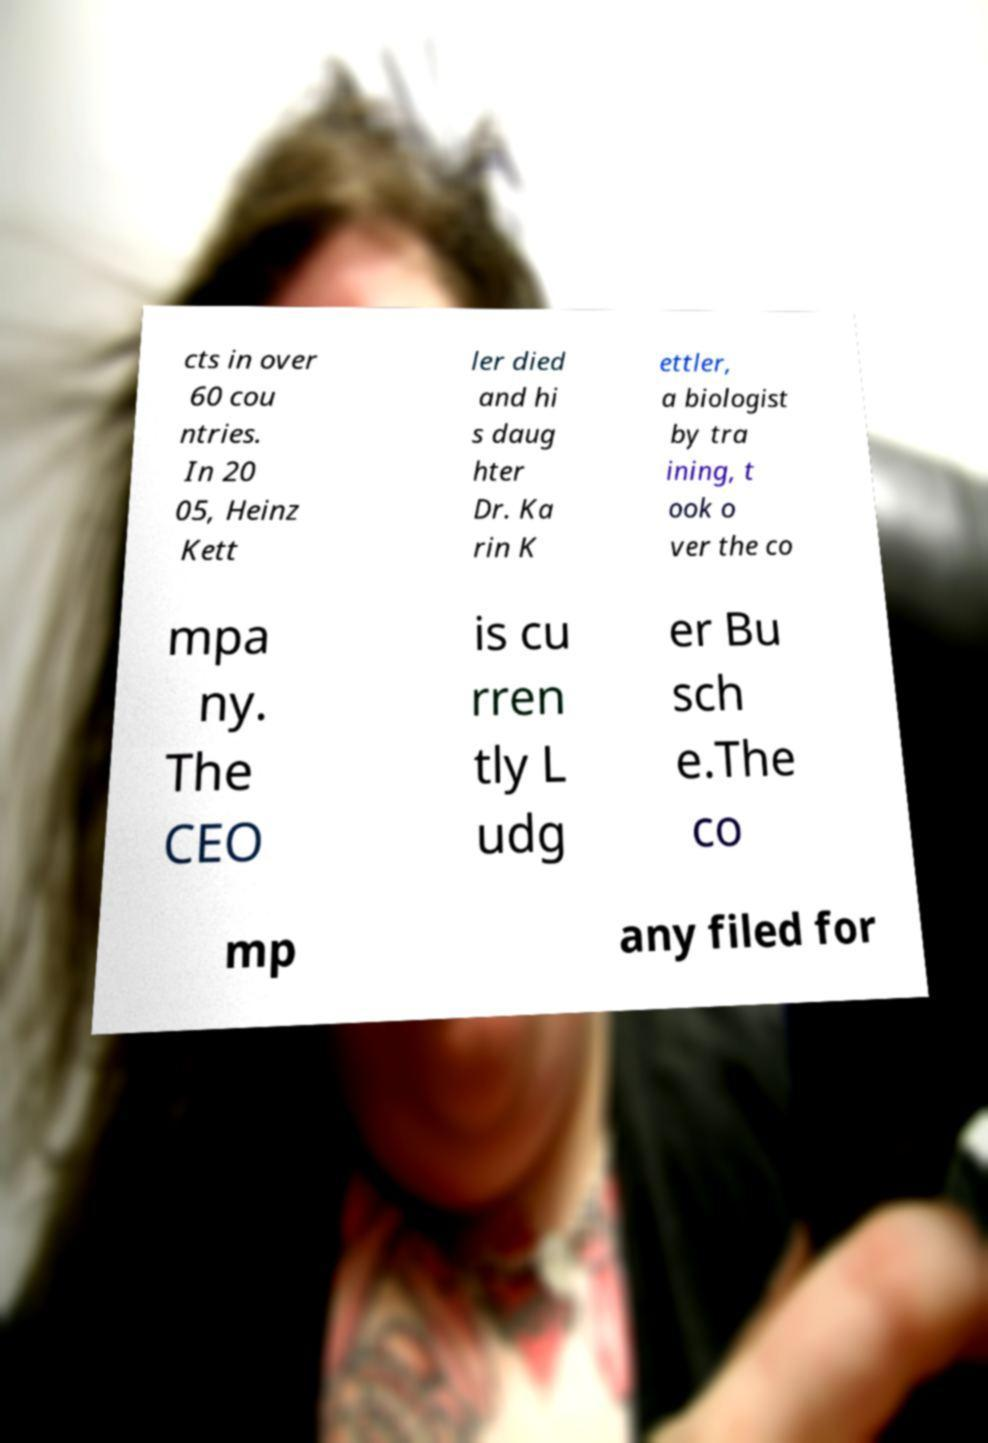For documentation purposes, I need the text within this image transcribed. Could you provide that? cts in over 60 cou ntries. In 20 05, Heinz Kett ler died and hi s daug hter Dr. Ka rin K ettler, a biologist by tra ining, t ook o ver the co mpa ny. The CEO is cu rren tly L udg er Bu sch e.The co mp any filed for 